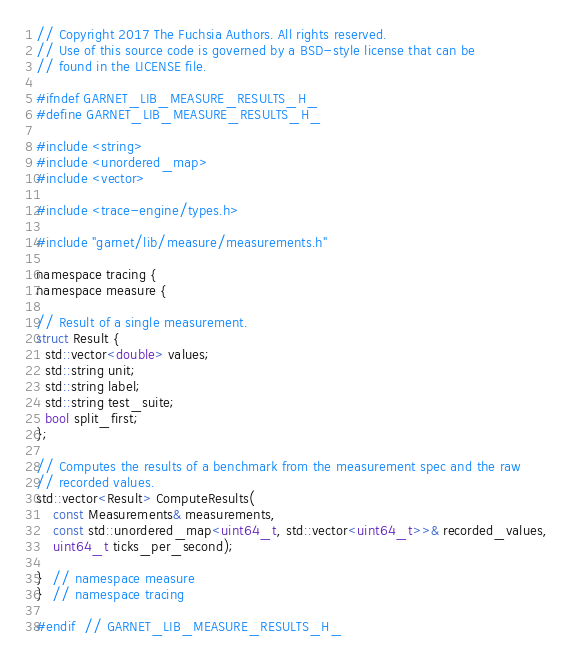<code> <loc_0><loc_0><loc_500><loc_500><_C_>// Copyright 2017 The Fuchsia Authors. All rights reserved.
// Use of this source code is governed by a BSD-style license that can be
// found in the LICENSE file.

#ifndef GARNET_LIB_MEASURE_RESULTS_H_
#define GARNET_LIB_MEASURE_RESULTS_H_

#include <string>
#include <unordered_map>
#include <vector>

#include <trace-engine/types.h>

#include "garnet/lib/measure/measurements.h"

namespace tracing {
namespace measure {

// Result of a single measurement.
struct Result {
  std::vector<double> values;
  std::string unit;
  std::string label;
  std::string test_suite;
  bool split_first;
};

// Computes the results of a benchmark from the measurement spec and the raw
// recorded values.
std::vector<Result> ComputeResults(
    const Measurements& measurements,
    const std::unordered_map<uint64_t, std::vector<uint64_t>>& recorded_values,
    uint64_t ticks_per_second);

}  // namespace measure
}  // namespace tracing

#endif  // GARNET_LIB_MEASURE_RESULTS_H_
</code> 